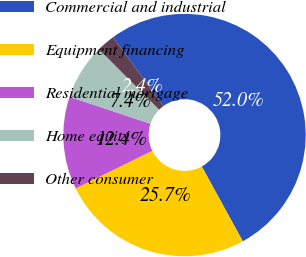<chart> <loc_0><loc_0><loc_500><loc_500><pie_chart><fcel>Commercial and industrial<fcel>Equipment financing<fcel>Residential mortgage<fcel>Home equity<fcel>Other consumer<nl><fcel>52.05%<fcel>25.73%<fcel>12.37%<fcel>7.41%<fcel>2.45%<nl></chart> 